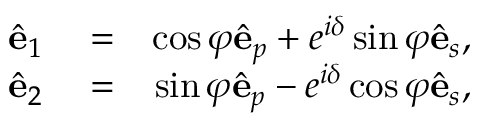<formula> <loc_0><loc_0><loc_500><loc_500>\begin{array} { r l r } { \hat { e } _ { 1 } } & = } & { \cos \varphi \hat { e } _ { p } + e ^ { i \delta } \sin \varphi \hat { e } _ { s } , } \\ { \hat { e } _ { 2 } } & = } & { \sin \varphi \hat { e } _ { p } - e ^ { i \delta } \cos \varphi \hat { e } _ { s } , } \end{array}</formula> 